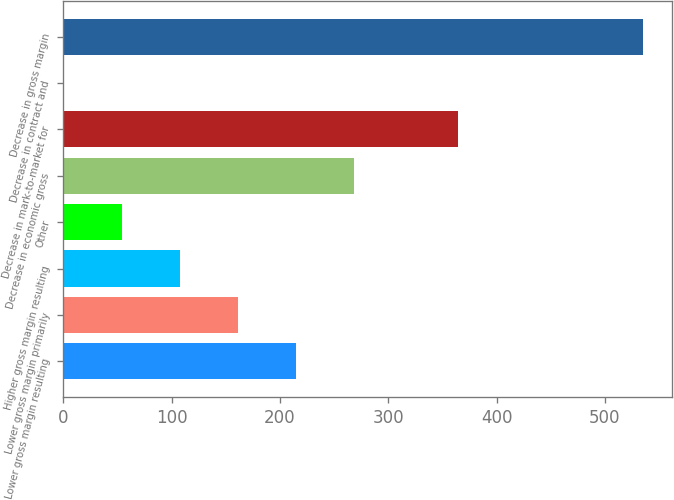<chart> <loc_0><loc_0><loc_500><loc_500><bar_chart><fcel>Lower gross margin resulting<fcel>Lower gross margin primarily<fcel>Higher gross margin resulting<fcel>Other<fcel>Decrease in economic gross<fcel>Decrease in mark-to-market for<fcel>Decrease in contract and<fcel>Decrease in gross margin<nl><fcel>214.6<fcel>161.2<fcel>107.8<fcel>54.4<fcel>268<fcel>364<fcel>1<fcel>535<nl></chart> 